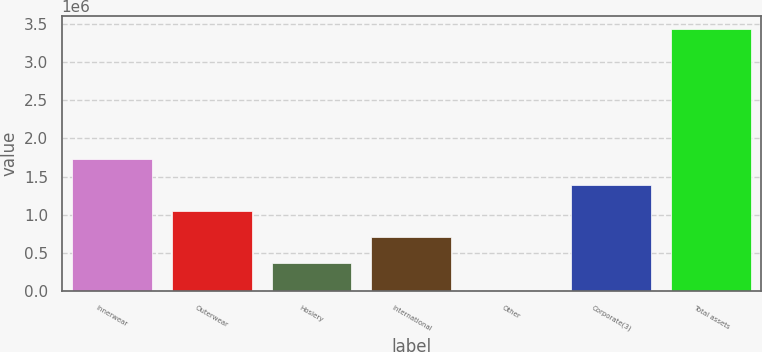Convert chart. <chart><loc_0><loc_0><loc_500><loc_500><bar_chart><fcel>Innerwear<fcel>Outerwear<fcel>Hosiery<fcel>International<fcel>Other<fcel>Corporate(3)<fcel>Total assets<nl><fcel>1.72871e+06<fcel>1.04594e+06<fcel>363180<fcel>704562<fcel>21798<fcel>1.38733e+06<fcel>3.43562e+06<nl></chart> 